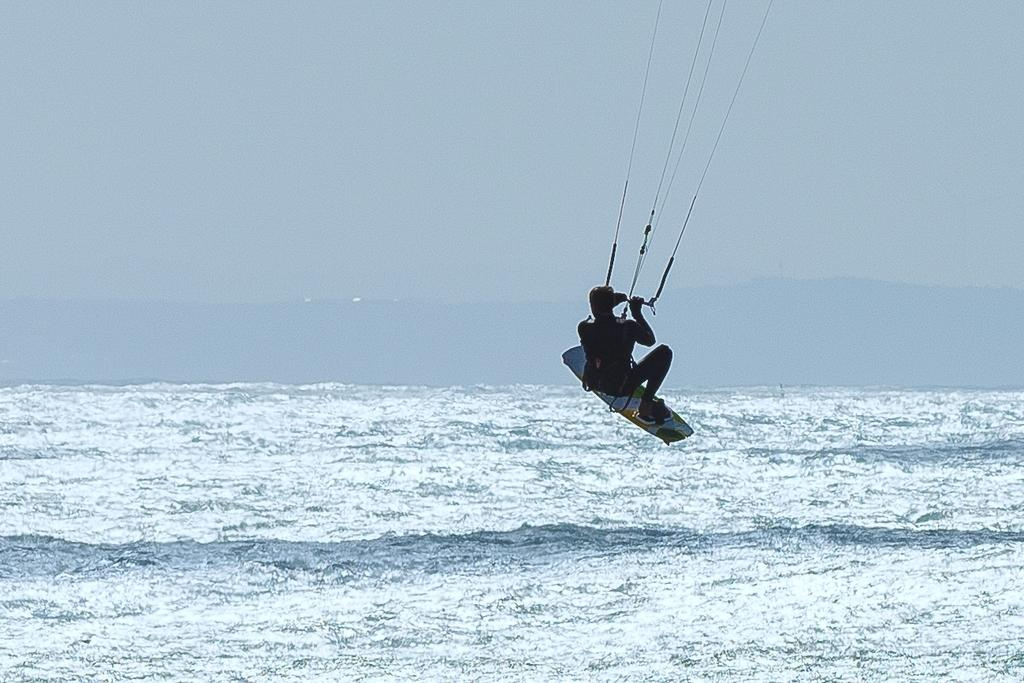What is the main subject of the image? There is a person in the image. What is the person holding in the image? The person is holding a rod with strings. What is the person wearing in the image? The person is wearing a surfboard. What is the person doing in the image? The person is flying in the air. What can be seen at the bottom of the image? There is water with tides at the bottom of the image. What is visible at the top of the image? There is sky at the top of the image. Where is the parcel placed on the table in the image? There is no parcel or table present in the image. Can you describe the street where the person is flying in the image? There is no street visible in the image; the person is flying in the air above water and sky. 